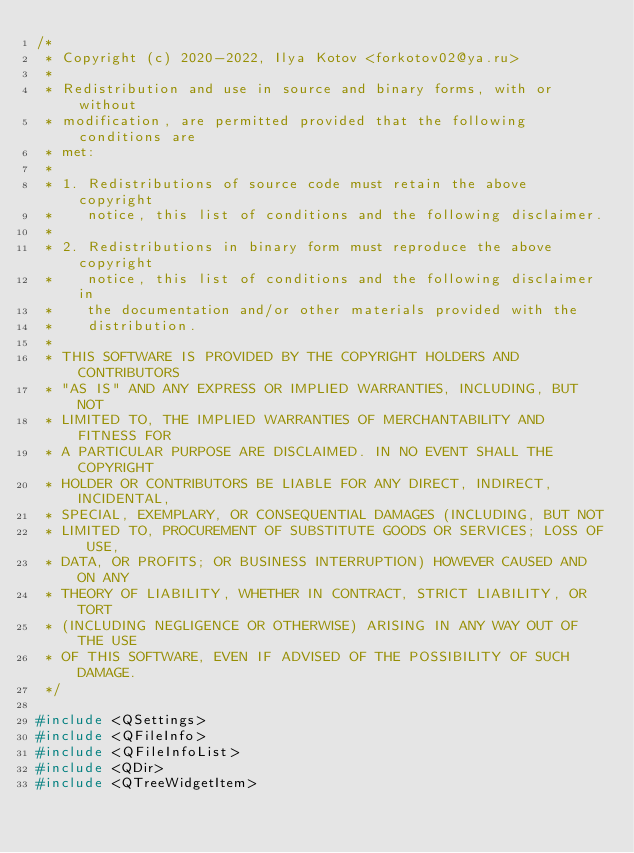Convert code to text. <code><loc_0><loc_0><loc_500><loc_500><_C++_>/*
 * Copyright (c) 2020-2022, Ilya Kotov <forkotov02@ya.ru>
 *
 * Redistribution and use in source and binary forms, with or without
 * modification, are permitted provided that the following conditions are
 * met:
 *
 * 1. Redistributions of source code must retain the above copyright
 *    notice, this list of conditions and the following disclaimer.
 *
 * 2. Redistributions in binary form must reproduce the above copyright
 *    notice, this list of conditions and the following disclaimer in
 *    the documentation and/or other materials provided with the
 *    distribution.
 *
 * THIS SOFTWARE IS PROVIDED BY THE COPYRIGHT HOLDERS AND CONTRIBUTORS
 * "AS IS" AND ANY EXPRESS OR IMPLIED WARRANTIES, INCLUDING, BUT NOT
 * LIMITED TO, THE IMPLIED WARRANTIES OF MERCHANTABILITY AND FITNESS FOR
 * A PARTICULAR PURPOSE ARE DISCLAIMED. IN NO EVENT SHALL THE COPYRIGHT
 * HOLDER OR CONTRIBUTORS BE LIABLE FOR ANY DIRECT, INDIRECT, INCIDENTAL,
 * SPECIAL, EXEMPLARY, OR CONSEQUENTIAL DAMAGES (INCLUDING, BUT NOT
 * LIMITED TO, PROCUREMENT OF SUBSTITUTE GOODS OR SERVICES; LOSS OF USE,
 * DATA, OR PROFITS; OR BUSINESS INTERRUPTION) HOWEVER CAUSED AND ON ANY
 * THEORY OF LIABILITY, WHETHER IN CONTRACT, STRICT LIABILITY, OR TORT
 * (INCLUDING NEGLIGENCE OR OTHERWISE) ARISING IN ANY WAY OUT OF THE USE
 * OF THIS SOFTWARE, EVEN IF ADVISED OF THE POSSIBILITY OF SUCH DAMAGE.
 */

#include <QSettings>
#include <QFileInfo>
#include <QFileInfoList>
#include <QDir>
#include <QTreeWidgetItem></code> 